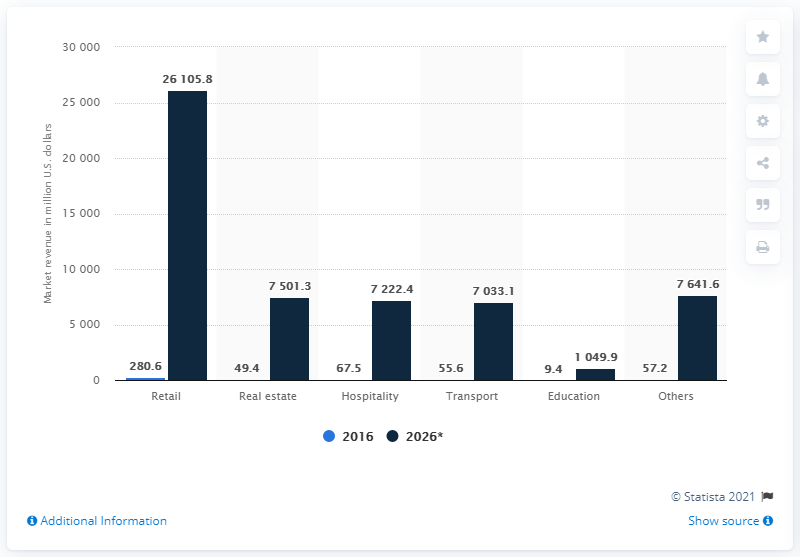Identify some key points in this picture. In 2016, the application of beacon technology in the retail industry was worth $280.6 million. 